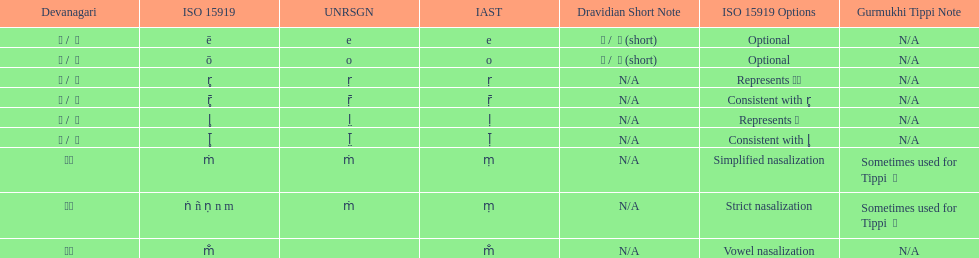What is listed previous to in iso 15919, &#7735; is used to represent &#2355;. under comments? For consistency with r̥. 